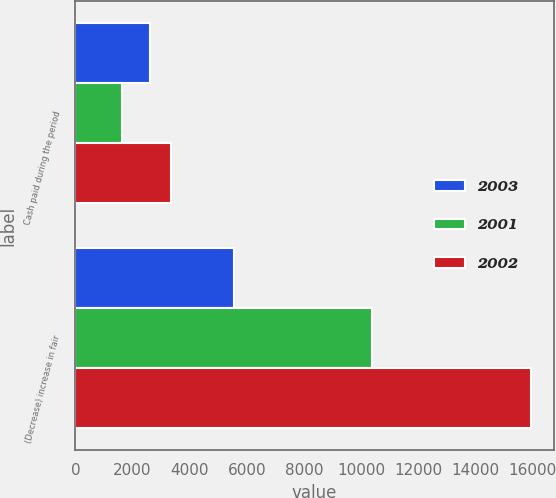<chart> <loc_0><loc_0><loc_500><loc_500><stacked_bar_chart><ecel><fcel>Cash paid during the period<fcel>(Decrease) increase in fair<nl><fcel>2003<fcel>2609<fcel>5564<nl><fcel>2001<fcel>1640<fcel>10389<nl><fcel>2002<fcel>3349<fcel>15953<nl></chart> 